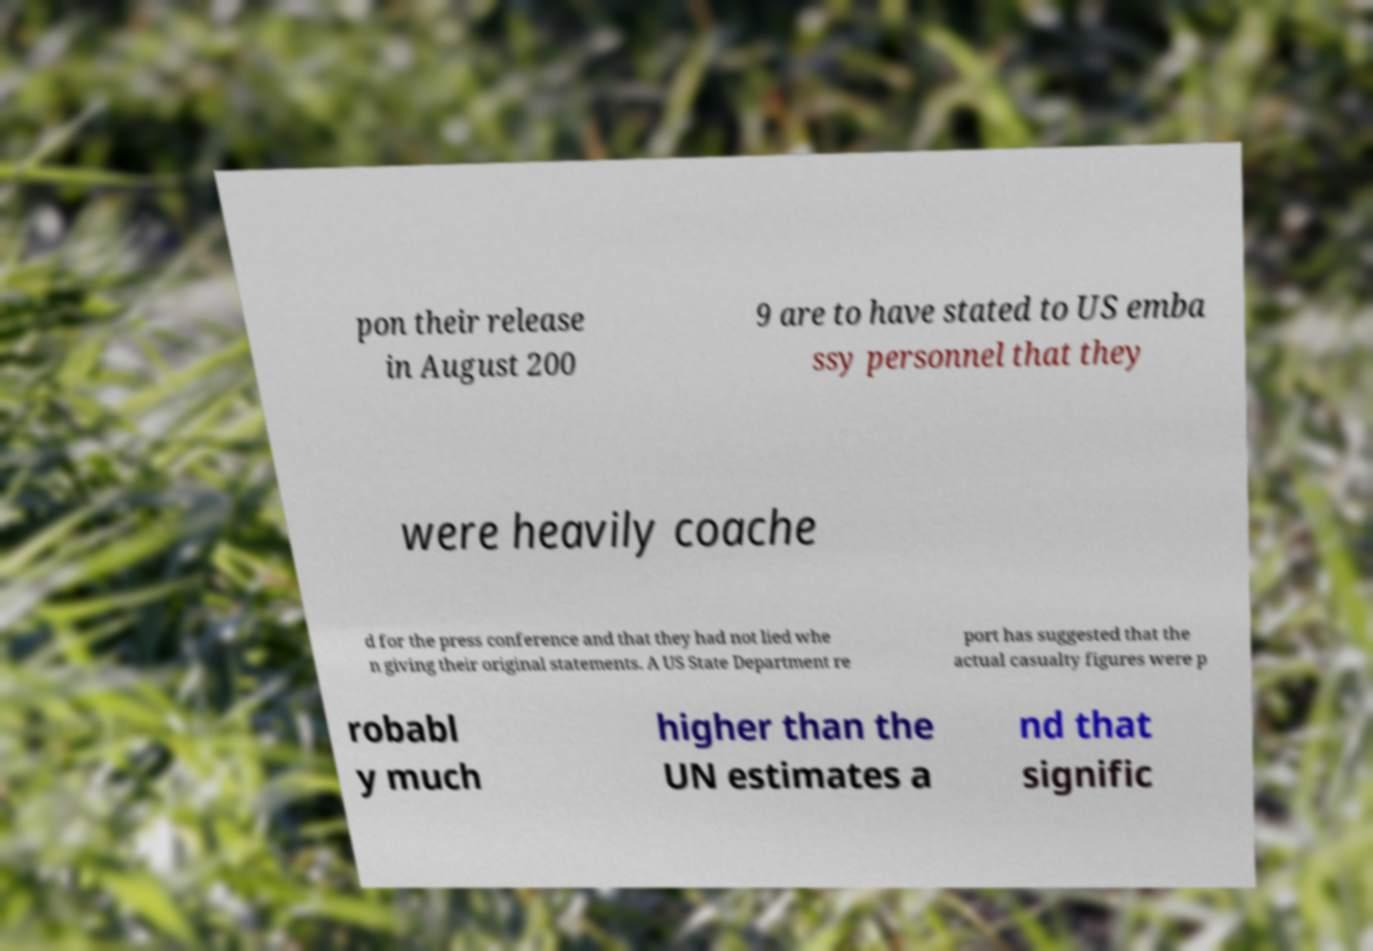I need the written content from this picture converted into text. Can you do that? pon their release in August 200 9 are to have stated to US emba ssy personnel that they were heavily coache d for the press conference and that they had not lied whe n giving their original statements. A US State Department re port has suggested that the actual casualty figures were p robabl y much higher than the UN estimates a nd that signific 